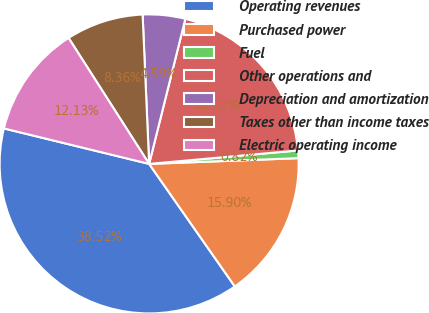<chart> <loc_0><loc_0><loc_500><loc_500><pie_chart><fcel>Operating revenues<fcel>Purchased power<fcel>Fuel<fcel>Other operations and<fcel>Depreciation and amortization<fcel>Taxes other than income taxes<fcel>Electric operating income<nl><fcel>38.52%<fcel>15.9%<fcel>0.82%<fcel>19.67%<fcel>4.59%<fcel>8.36%<fcel>12.13%<nl></chart> 